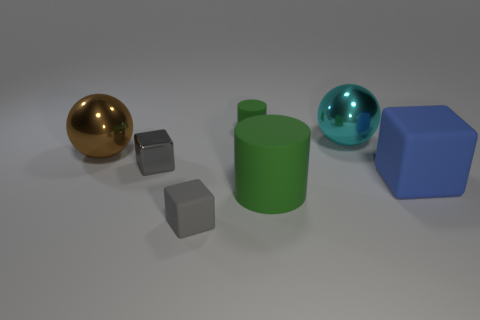There is a large rubber thing that is the same color as the tiny rubber cylinder; what shape is it?
Keep it short and to the point. Cylinder. Is the number of tiny blocks in front of the big green rubber object the same as the number of blue matte objects in front of the large brown sphere?
Provide a succinct answer. Yes. How many other objects are the same material as the blue block?
Your answer should be very brief. 3. Is the number of big metal balls left of the large blue object the same as the number of big rubber objects?
Offer a terse response. Yes. There is a gray metallic block; is its size the same as the green rubber cylinder in front of the brown shiny object?
Offer a terse response. No. What is the shape of the tiny thing that is in front of the large blue matte object?
Give a very brief answer. Cube. Are any cyan metallic spheres visible?
Provide a succinct answer. Yes. There is a metal ball on the left side of the gray shiny cube; is its size the same as the matte cube that is in front of the blue thing?
Provide a succinct answer. No. What material is the large thing that is both left of the large cyan metallic sphere and on the right side of the big brown sphere?
Provide a succinct answer. Rubber. There is a big brown shiny sphere; what number of small rubber cylinders are to the left of it?
Ensure brevity in your answer.  0. 